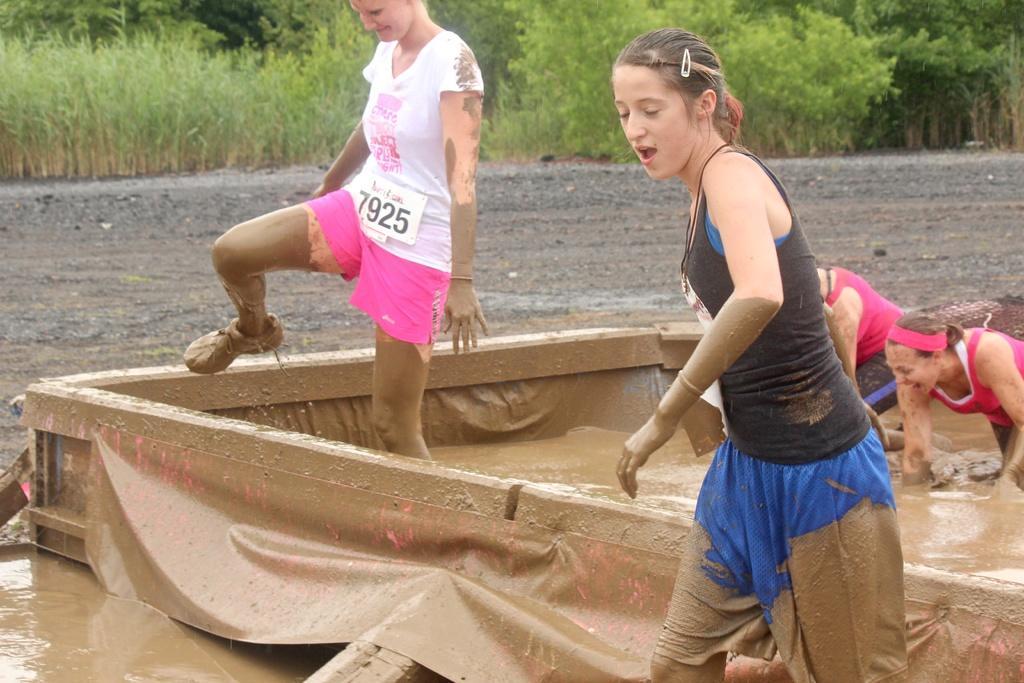Can you describe this image briefly? In this image in the foreground there are two women who are walking, and on the right side there are two women who are walking. And at the bottom there is a box, in that box there is some mud and water. In the background there are some plants and trees, and in the center there is a walkway. 